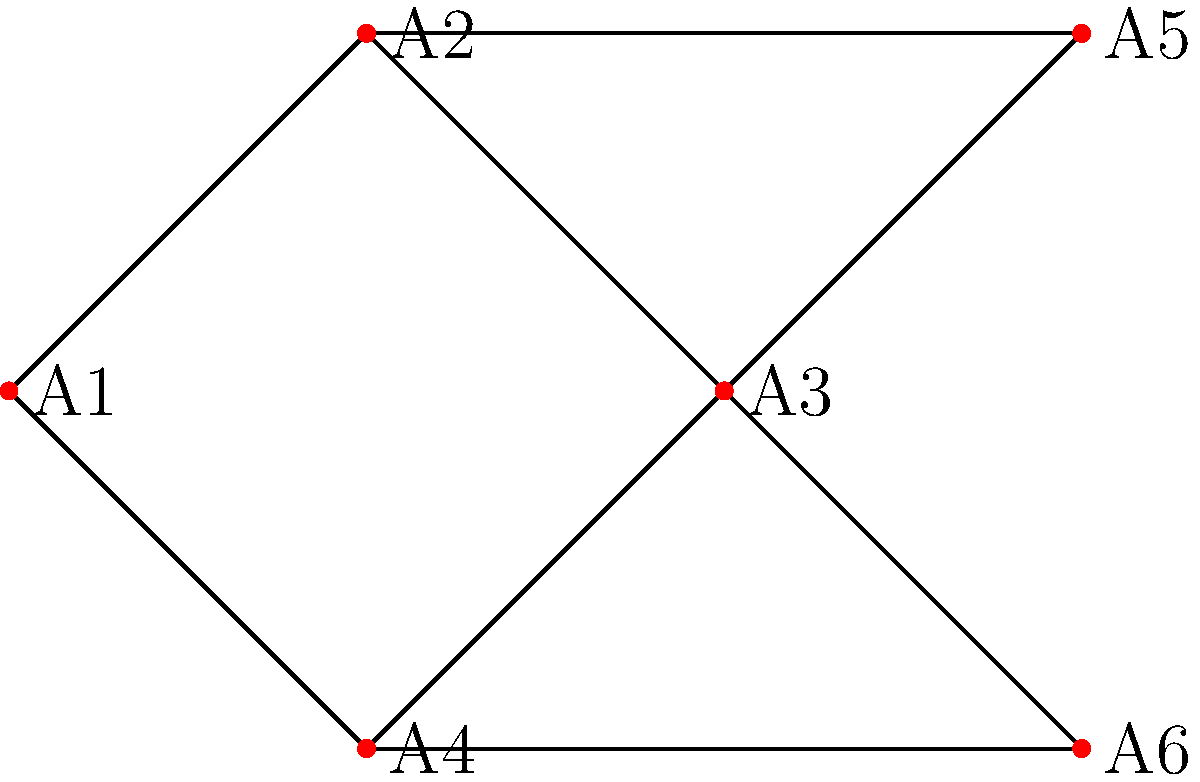In a national security operation, six agencies (A1 to A6) need to be assigned communication frequencies. Due to potential interference, agencies sharing a border cannot use the same frequency. Given the graph representing agency adjacencies, what is the minimum number of frequencies needed to ensure no conflicts? To solve this problem, we need to use the concept of graph coloring, where each color represents a unique frequency. The goal is to find the chromatic number of the graph, which is the minimum number of colors needed to color all vertices such that no adjacent vertices have the same color.

Step 1: Analyze the graph structure
- The graph has 6 vertices (A1 to A6) representing agencies.
- Edges between vertices represent adjacencies where frequencies cannot be shared.

Step 2: Identify the maximum degree
- The maximum degree in the graph is 4 (vertex A3).
- This gives us a starting upper bound of 5 colors (maximum degree + 1).

Step 3: Apply the greedy coloring algorithm
1. Start with A1: Assign color 1
2. A2: Adjacent to A1, assign color 2
3. A3: Adjacent to A1, A2, A4, A5, A6. Needs a new color, assign color 3
4. A4: Adjacent to A1, A3. Can use color 2
5. A5: Adjacent to A2, A3. Can use color 1
6. A6: Adjacent to A3, A4. Can use color 1

Step 4: Count the number of colors used
- The coloring process used 3 distinct colors.

Step 5: Verify optimality
- The graph contains a triangle (A1-A2-A3), which requires at least 3 colors.
- No better coloring is possible, so 3 is the chromatic number.

Therefore, the minimum number of frequencies needed is 3.
Answer: 3 frequencies 